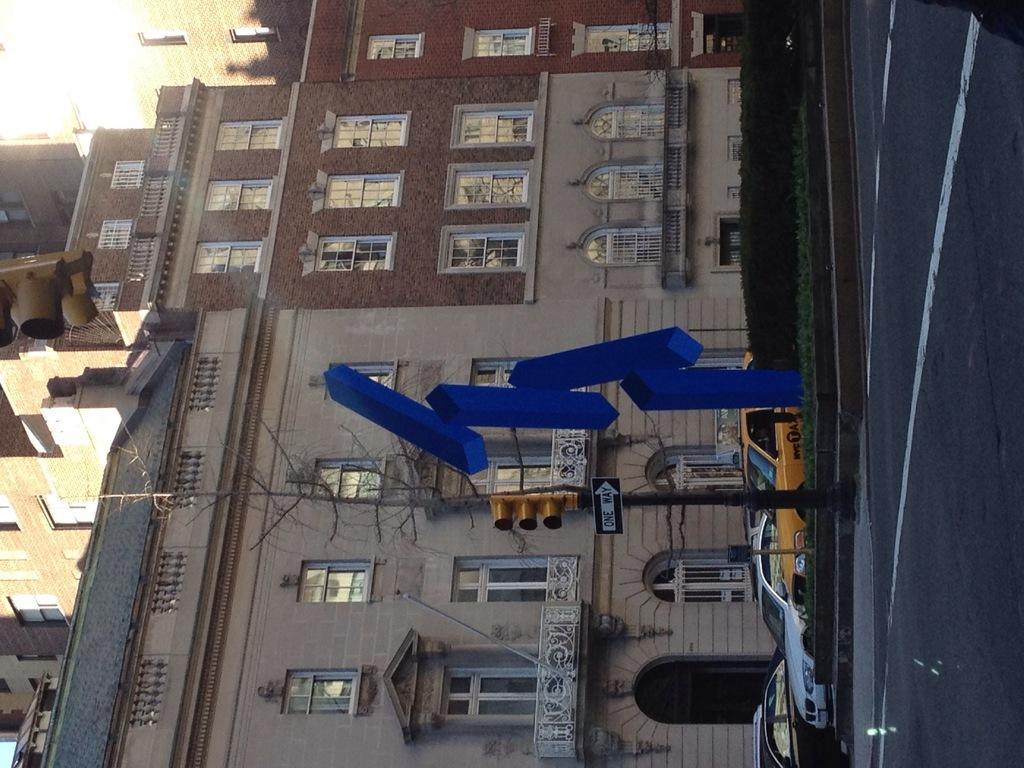Can you describe this image briefly? This image is in left direction. At the bottom of the image I can see few cars on the road and also there is a traffic signal pole which is placed beside the road. In the background, I can see the buildings along with the windows. 